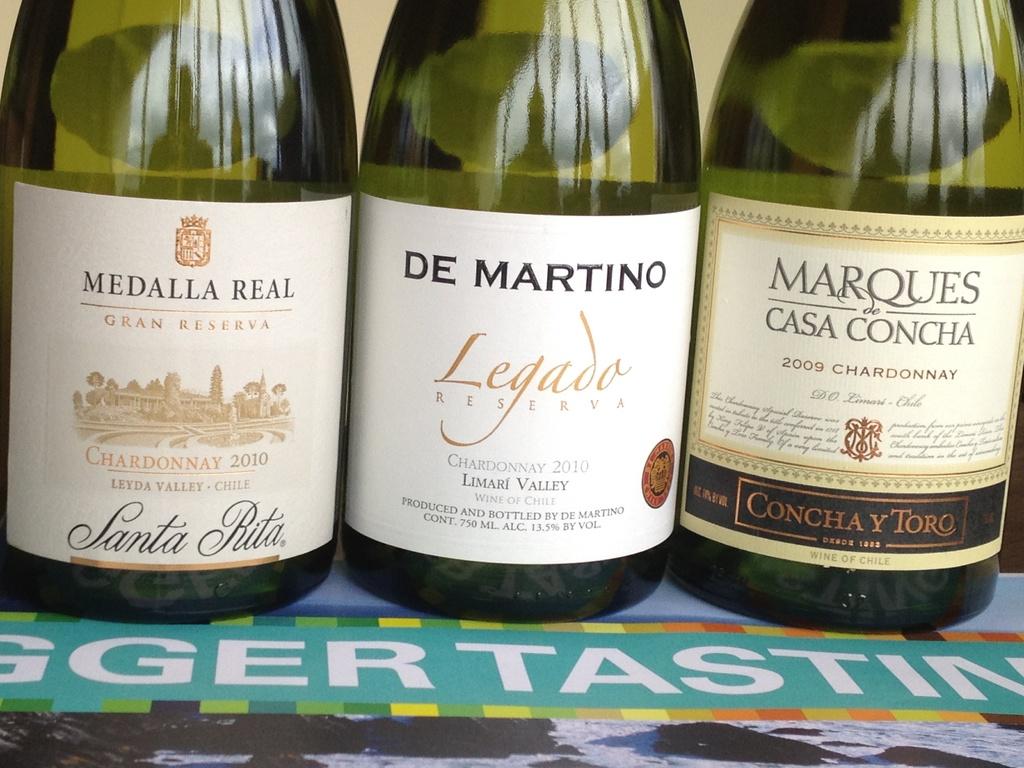Where are the de martino wine grapes grown?
Make the answer very short. Chile. 